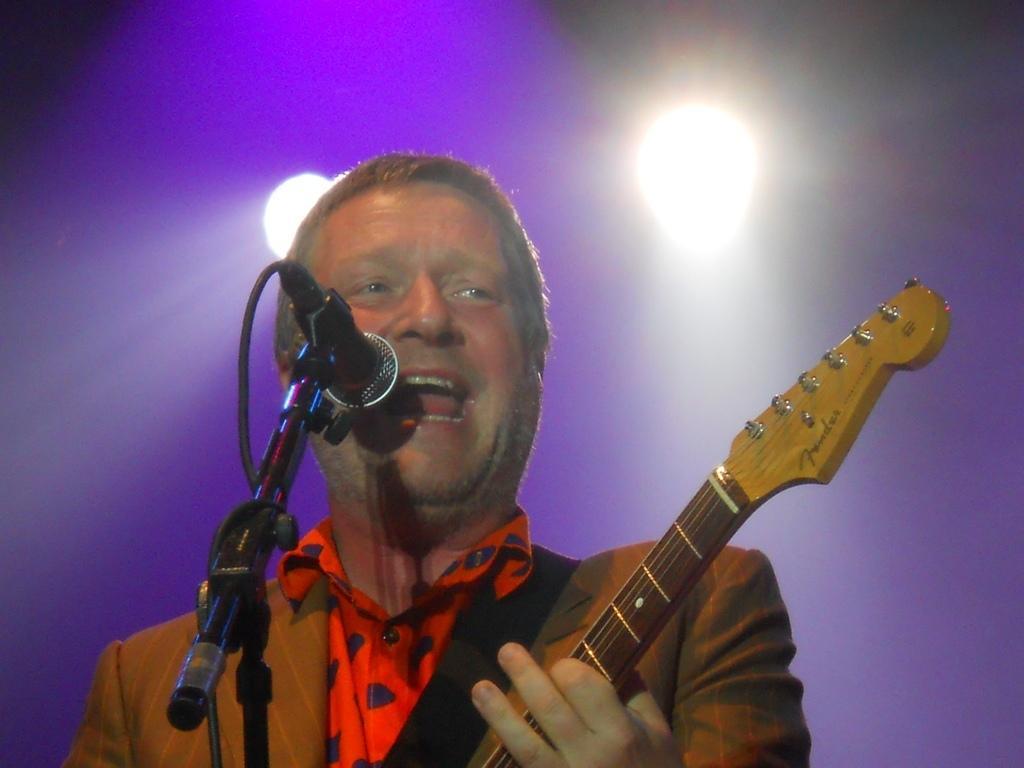Describe this image in one or two sentences. This man is playing a guitar and singing in-front of a mic. On top there are focusing lights. 